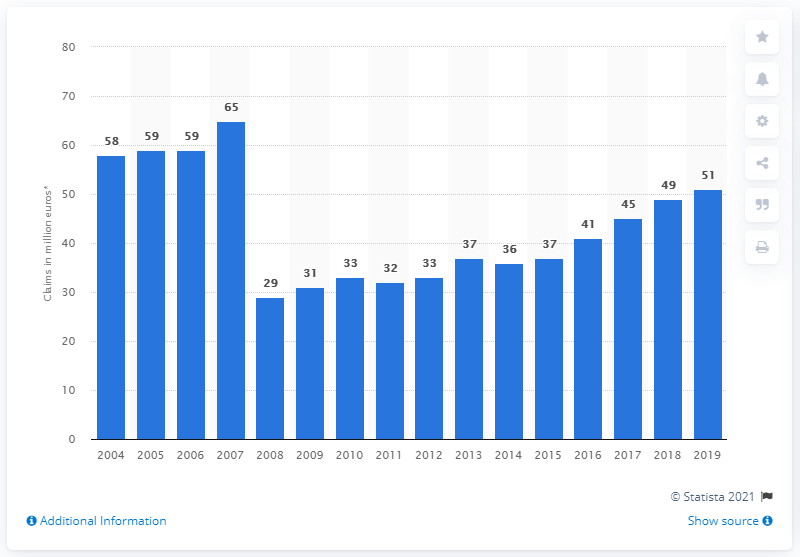Highlight a few significant elements in this photo. The total worth of motor insurance claims paid out by insurers in Malta in 2019 was approximately $51 million. 